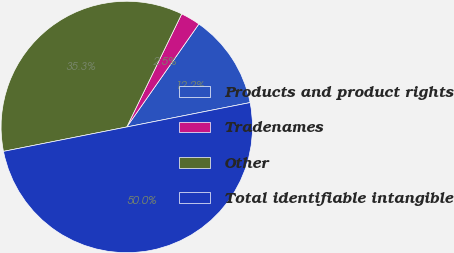<chart> <loc_0><loc_0><loc_500><loc_500><pie_chart><fcel>Products and product rights<fcel>Tradenames<fcel>Other<fcel>Total identifiable intangible<nl><fcel>12.17%<fcel>2.52%<fcel>35.31%<fcel>50.0%<nl></chart> 